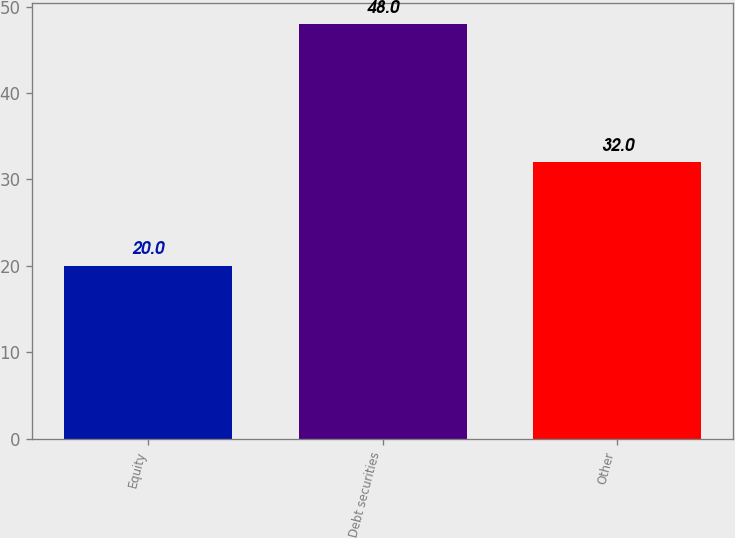Convert chart. <chart><loc_0><loc_0><loc_500><loc_500><bar_chart><fcel>Equity<fcel>Debt securities<fcel>Other<nl><fcel>20<fcel>48<fcel>32<nl></chart> 